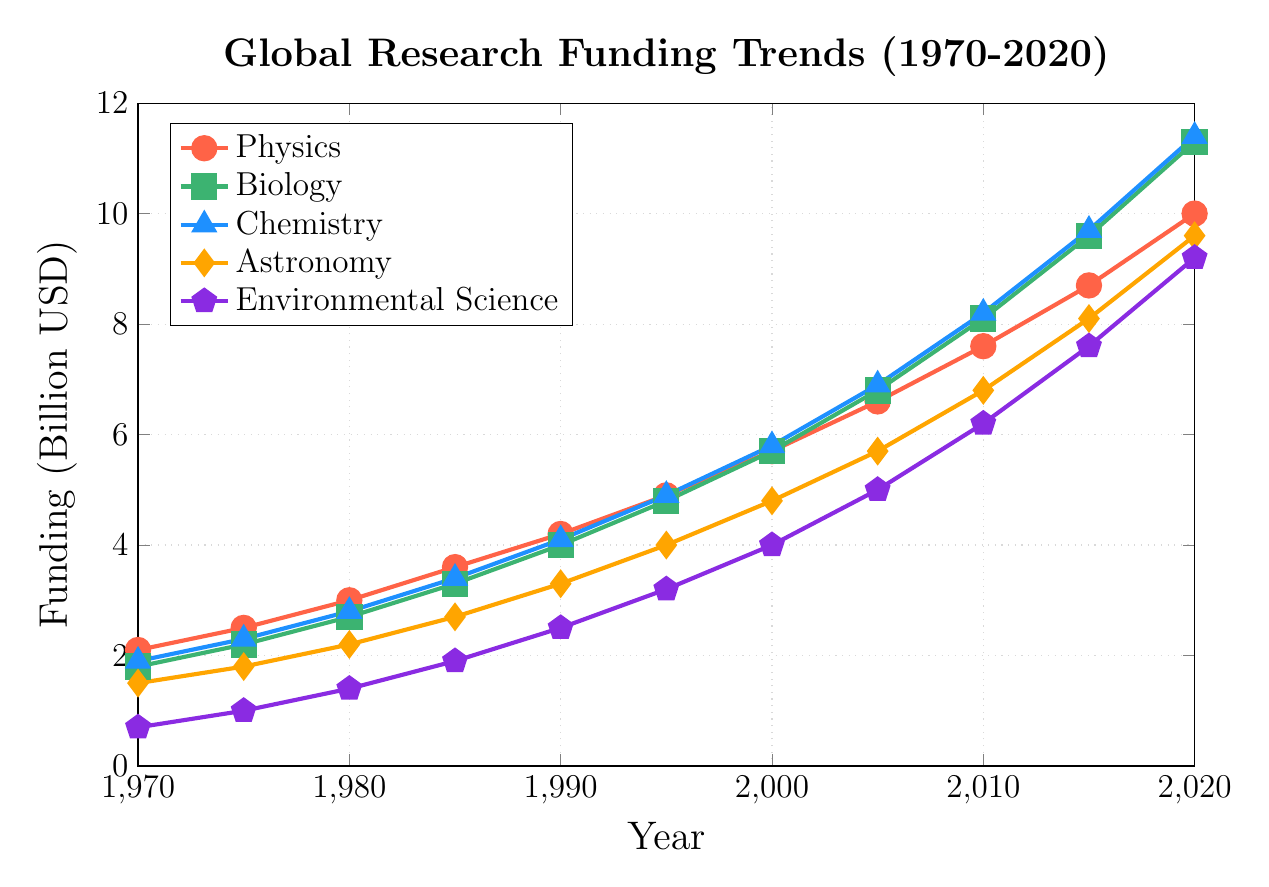Which discipline experienced the highest increase in funding from 1970 to 2020? To determine the discipline with the highest increase in funding over the period, we need to subtract the 1970 value from the 2020 value for each discipline and compare the results. Physics: 10.0 - 2.1 = 7.9, Biology: 11.3 - 1.8 = 9.5, Chemistry: 11.4 - 1.9 = 9.5, Astronomy: 9.6 - 1.5 = 8.1, Environmental Science: 9.2 - 0.7 = 8.5. Biology and Chemistry have the highest increase of 9.5 billion USD.
Answer: Biology and Chemistry Which year did Biology funding surpass Physics funding? By examining the graph, we see that from 1970 to 2000, Physics funding is higher than Biology funding. In 2005, Biology funding (6.8 billion USD) surpasses Physics funding (6.6 billion USD) for the first time.
Answer: 2005 How much more was the Environmental Science funding in 2020 compared to 1980? To find the increase in Environmental Science funding from 1980 to 2020, subtract the funding in 1980 from the funding in 2020. This is 9.2 - 1.4 = 7.8 billion USD.
Answer: 7.8 billion USD Which discipline had the least funding in 1995, and what was the amount? To find the discipline with the least funding in 1995, we compare the funding for all disciplines in that year. Environmental Science has the least funding in 1995 with 3.2 billion USD.
Answer: Environmental Science, 3.2 billion USD What is the average funding for Physics over the entire period? To calculate the average funding, add the funding amounts for Physics from 1970 to 2020, and then divide by the number of years. (2.1 + 2.5 + 3.0 + 3.6 + 4.2 + 4.9 + 5.7 + 6.6 + 7.6 + 8.7 + 10.0)/11 = 5.64 billion USD.
Answer: 5.64 billion USD In which year was the funding difference between Chemistry and Physics the smallest? We look at the differences in funding between Chemistry and Physics for each year: 1970: 1.9 - 2.1 = -0.2, 1975: 2.3 - 2.5 = -0.2, 1980: 2.8 - 3.0 = -0.2, 1985: 3.4 - 3.6 = -0.2, 1990: 4.1 - 4.2 = -0.1, 1995: 4.9 - 4.9 = 0.0, 2000: 5.8 - 5.7 = 0.1, 2005: 6.9 - 6.6 = 0.3, 2010: 8.2 - 7.6 = 0.6, 2015: 9.7 - 8.7 = 1.0, 2020: 11.4 - 10.0 = 1.4. The smallest difference is in 1995 with a difference of 0.0.
Answer: 1995 By how much did funding for Astronomy increase from 2000 to 2010? To find the increase, subtract the 2000 value from the 2010 value for Astronomy. 6.8 - 4.8 = 2.0 billion USD.
Answer: 2.0 billion USD In 2010, which discipline had the second-highest funding, and what was the amount? By examining the 2010 data, the funding amounts are as follows: Physics: 7.6, Biology: 8.1, Chemistry: 8.2, Astronomy: 6.8, Environmental Science: 6.2. The second-highest funding is for Biology with 8.1 billion USD.
Answer: Biology, 8.1 billion USD Which discipline had the fastest rate of funding growth from 1970 to 2020? To determine the fastest rate, we consider the initial and final values for each discipline and the growth over the 50-year period: Physics: (10.0 - 2.1)/50 = 0.158, Biology: (11.3 - 1.8)/50 = 0.19, Chemistry: (11.4 - 1.9)/50 = 0.19, Astronomy: (9.6 - 1.5)/50 = 0.162, Environmental Science: (9.2 - 0.7)/50 = 0.17. Biology and Chemistry have the fastest rate of growth with 0.19 billion USD per year.
Answer: Biology and Chemistry 